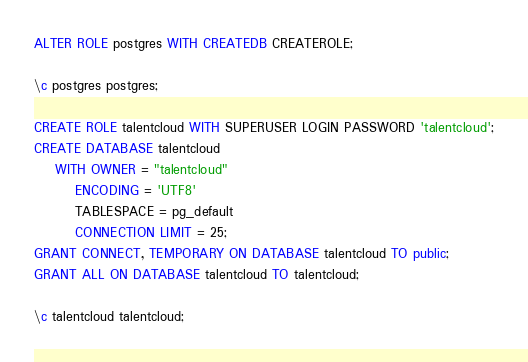Convert code to text. <code><loc_0><loc_0><loc_500><loc_500><_SQL_>ALTER ROLE postgres WITH CREATEDB CREATEROLE;

\c postgres postgres;

CREATE ROLE talentcloud WITH SUPERUSER LOGIN PASSWORD 'talentcloud';
CREATE DATABASE talentcloud
    WITH OWNER = "talentcloud"
        ENCODING = 'UTF8'
        TABLESPACE = pg_default
        CONNECTION LIMIT = 25;
GRANT CONNECT, TEMPORARY ON DATABASE talentcloud TO public;
GRANT ALL ON DATABASE talentcloud TO talentcloud;

\c talentcloud talentcloud;
</code> 